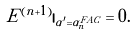<formula> <loc_0><loc_0><loc_500><loc_500>E ^ { ( n + 1 ) } | _ { \alpha ^ { \prime } = \alpha _ { n } ^ { F A C } } = 0 .</formula> 